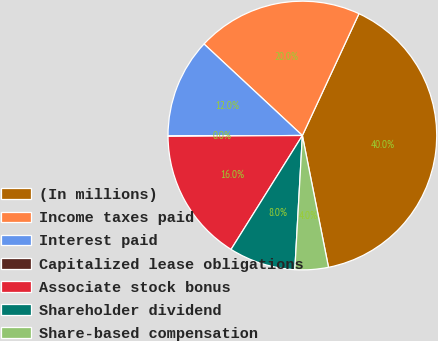Convert chart to OTSL. <chart><loc_0><loc_0><loc_500><loc_500><pie_chart><fcel>(In millions)<fcel>Income taxes paid<fcel>Interest paid<fcel>Capitalized lease obligations<fcel>Associate stock bonus<fcel>Shareholder dividend<fcel>Share-based compensation<nl><fcel>39.96%<fcel>19.99%<fcel>12.0%<fcel>0.02%<fcel>16.0%<fcel>8.01%<fcel>4.01%<nl></chart> 